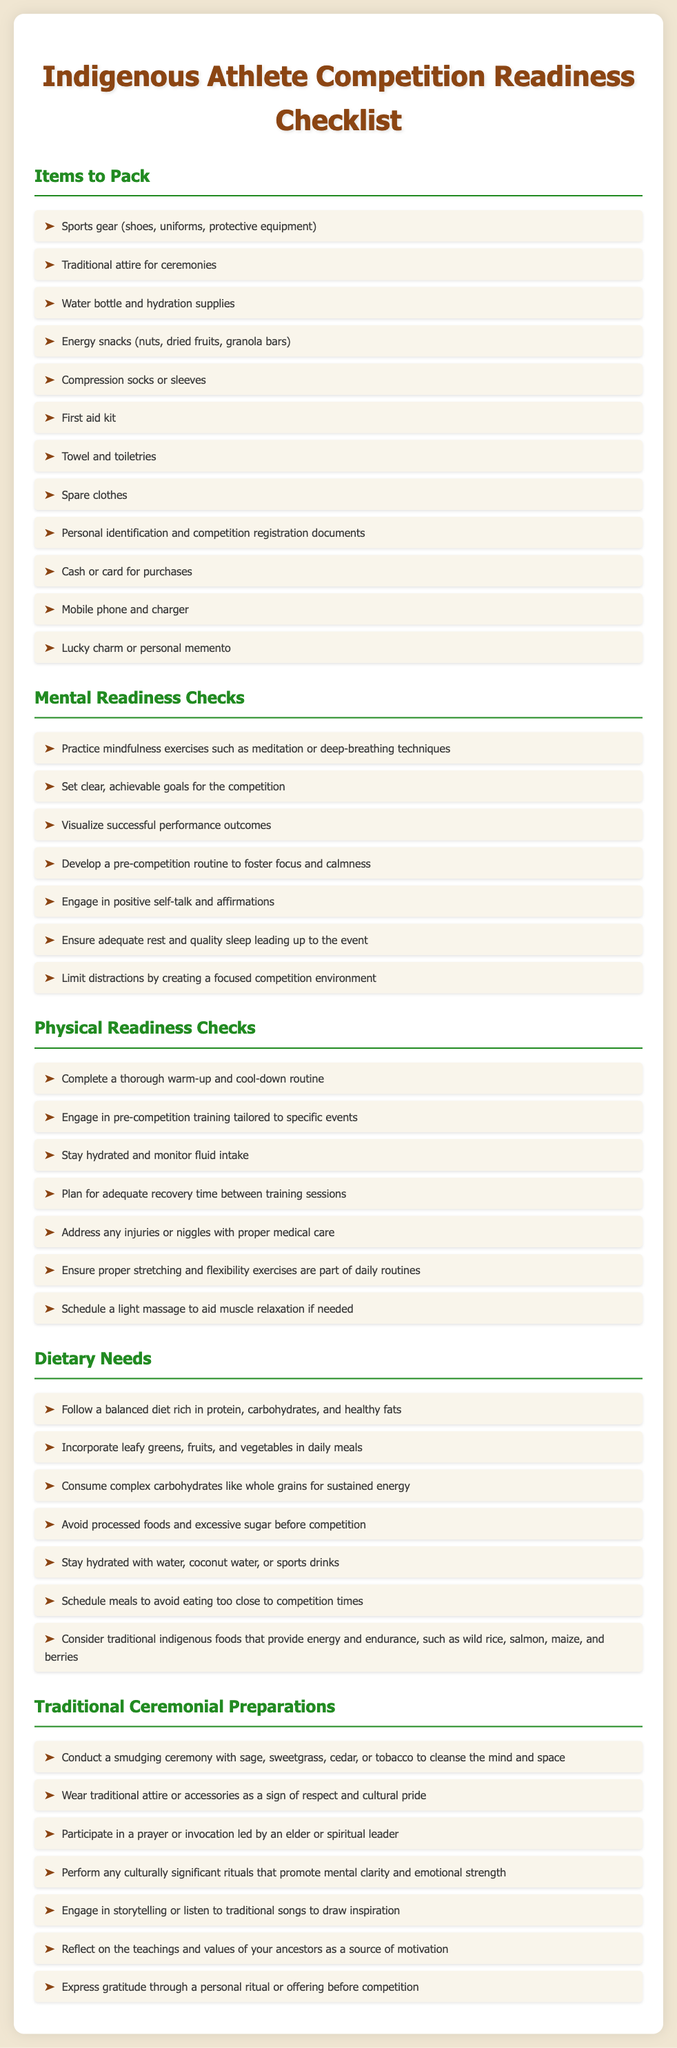What are the items to pack for competition? The items to pack are listed in the "Items to Pack" section, which includes sports gear, traditional attire, water bottle, energy snacks, and more.
Answer: sports gear, traditional attire, water bottle, energy snacks, compression socks, first aid kit, towel, spare clothes, personal identification, cash, mobile phone, lucky charm What is a mental readiness check that involves visualization? The mental readiness checks involve setting goals and visualization, specifically mentioned in the "Mental Readiness Checks" section.
Answer: Visualize successful performance outcomes How many dietary needs are listed in the document? The document contains a specific number of dietary needs in the "Dietary Needs" section.
Answer: seven What should you do to stay hydrated? Staying hydrated is addressed in the "Dietary Needs" section with specific suggestions for fluids.
Answer: water, coconut water, or sports drinks What is one of the traditional ceremonial preparations mentioned? The document outlines traditional ceremonial preparations that include cleansing rituals and wearing traditional attire.
Answer: Conduct a smudging ceremony Which section covers physical readiness checks? The document contains specific sections; the section titled "Physical Readiness Checks" addresses physical readiness.
Answer: Physical Readiness Checks What is included in the list of energy snacks? The list of energy snacks is detailed in the "Items to Pack" section, specifically seeking types of snacks.
Answer: nuts, dried fruits, granola bars What mental exercise is recommended before a competition? The document mentions several mental exercises, focusing on an effective external resource.
Answer: mindfulness exercises How can athletes express gratitude before competition? There are numerous ways outlined in the "Traditional Ceremonial Preparations," which highlight the significance of personal rituals.
Answer: personal ritual or offering 